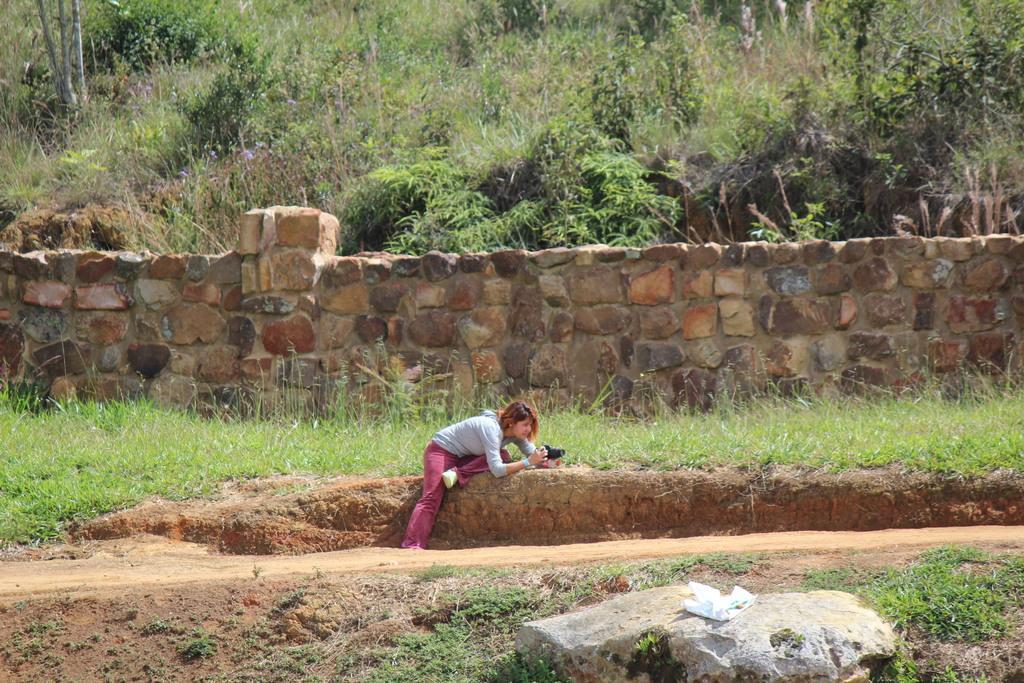Can you describe this image briefly? In this image in the center there is one woman who is holding a camera and at the bottom there is grass and some rocks, and in the background there are some trees and a wall and some plants. 